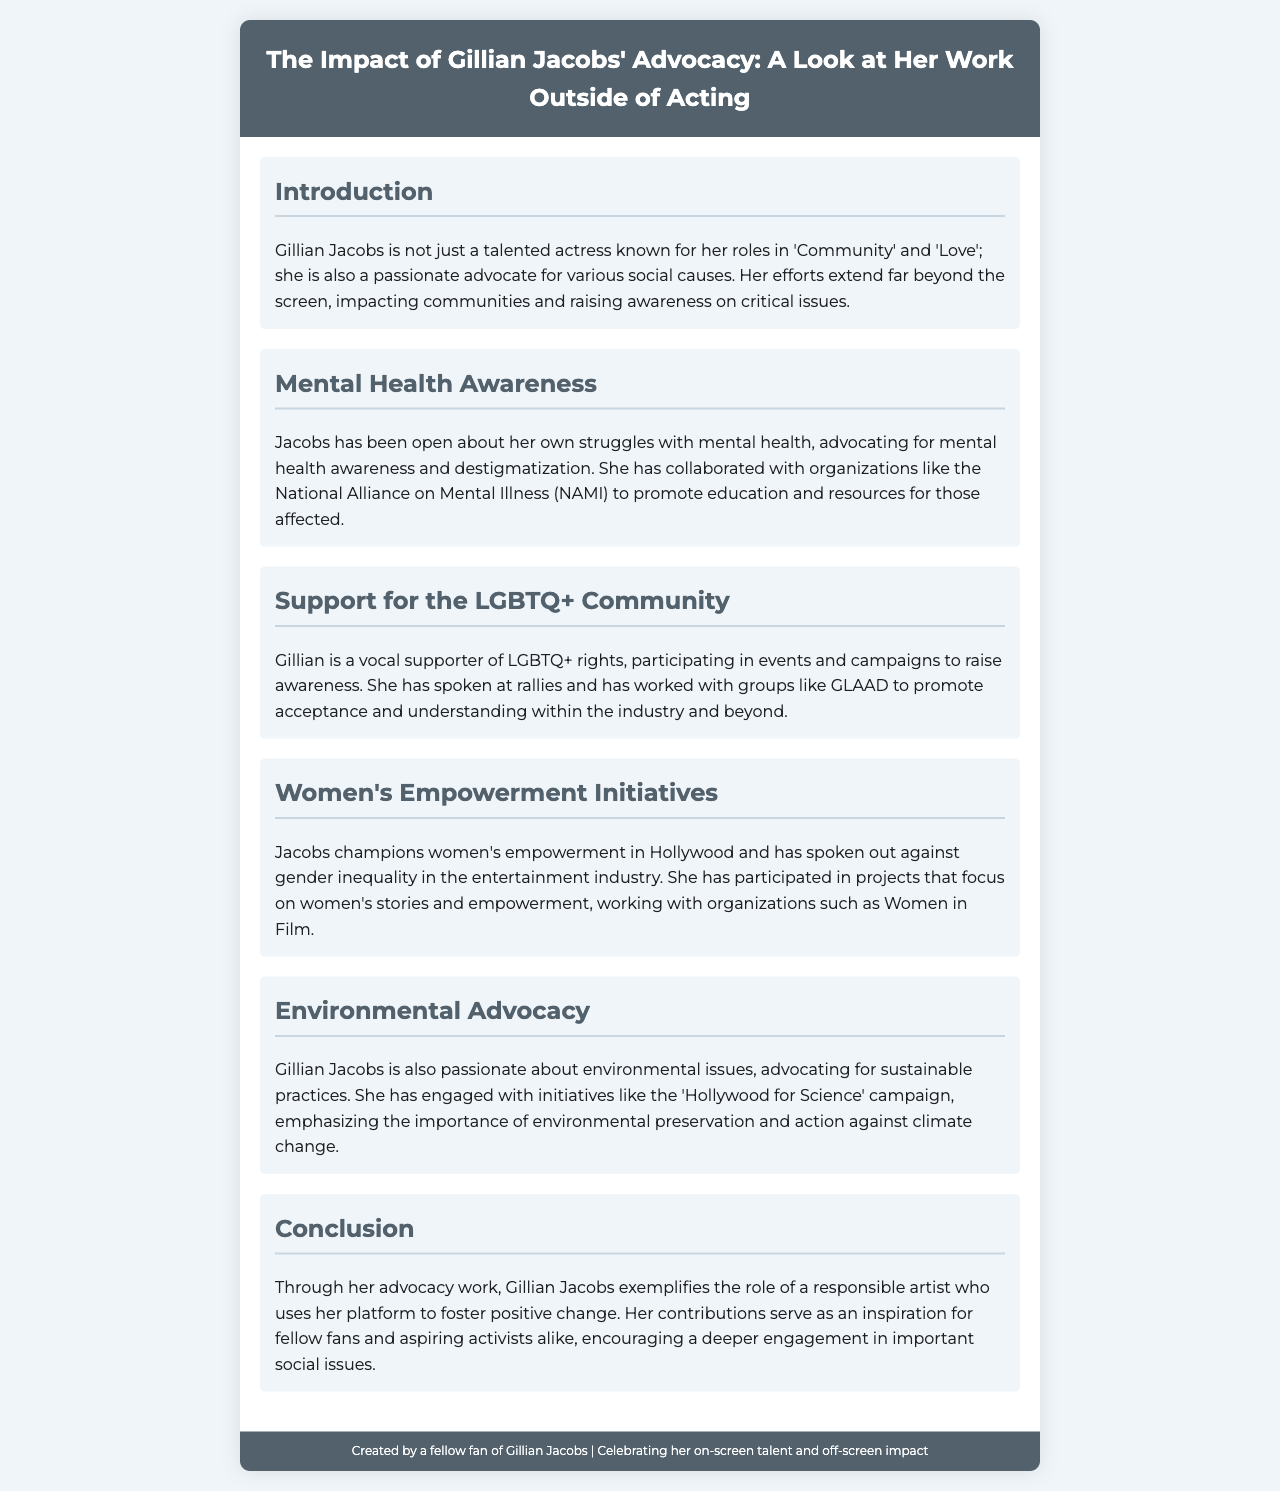what is Gillian Jacobs' notable role in 'Community'? The document mentions her talent as an actress known for her role in 'Community'.
Answer: 'Community' which organization has Gillian Jacobs collaborated with for mental health advocacy? The brochure specifically names the National Alliance on Mental Illness (NAMI) in relation to her advocacy work.
Answer: NAMI what issue does Gillian Jacobs advocate for concerning the entertainment industry? The document highlights her efforts against gender inequality in Hollywood.
Answer: gender inequality which campaign emphasizes environmental preservation that Jacobs is involved with? The brochure refers to her engagement with the 'Hollywood for Science' campaign concerning environmental issues.
Answer: Hollywood for Science what kind of rights does Gillian Jacobs strongly support? The document states that she is a vocal supporter of LGBTQ+ rights.
Answer: LGBTQ+ rights how does Gillian Jacobs contribute to women's empowerment? The brochure describes her participation in projects focusing on women's stories and empowerment in Hollywood.
Answer: women's empowerment what is a key theme in the conclusion of the brochure? The conclusion emphasizes her role as a responsible artist using her platform to foster positive change.
Answer: responsible artist which social issue is Gillian Jacobs not mentioned as advocating for in the brochure? The document provides information on several advocacy areas but does not mention disability rights.
Answer: disability rights 